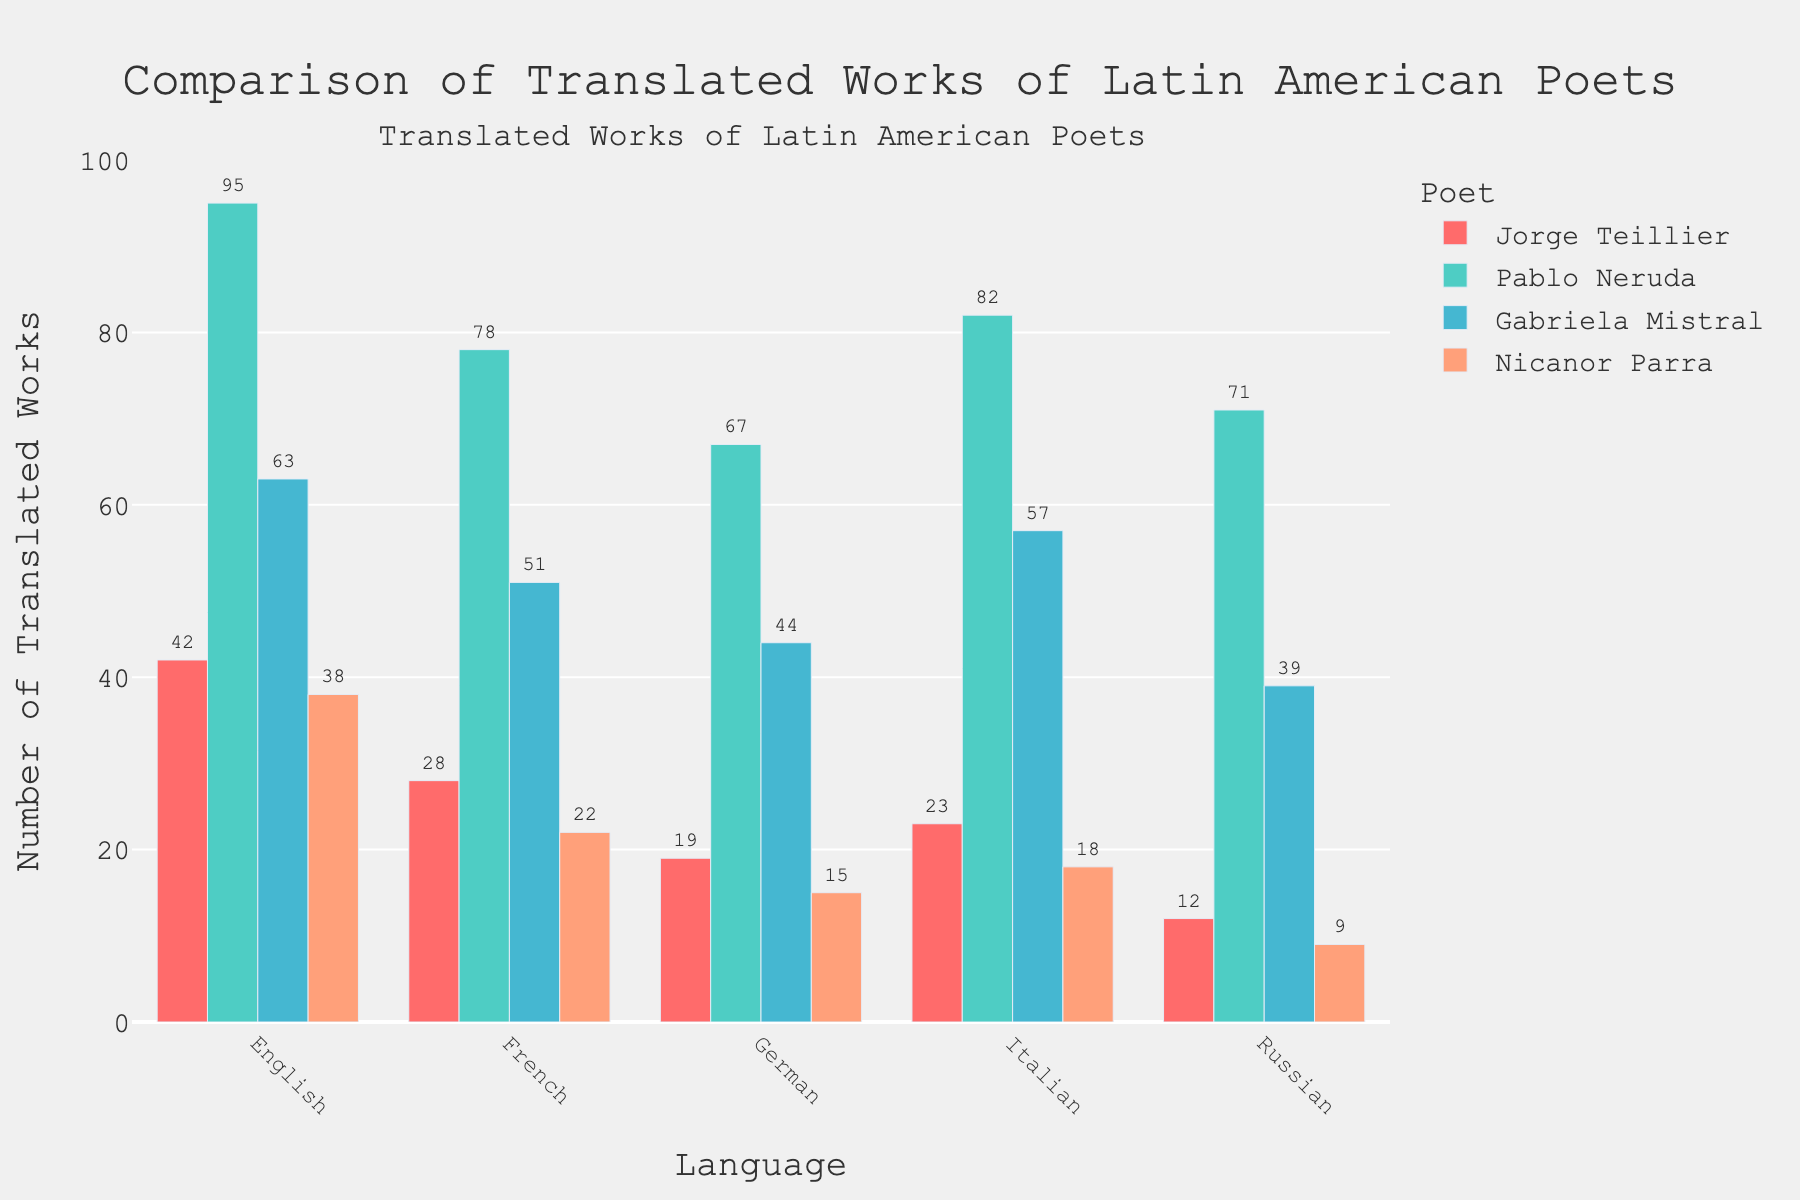Which poet has the highest number of translated works in English? To determine which poet has the highest number of translated works in English, we look for the tallest bar within the "English" category. The tallest bar in the "English" category corresponds to Pablo Neruda with 95 translated works.
Answer: Pablo Neruda How does Jorge Teillier's number of translated works in French compare to his translated works in Italian? To compare Jorge Teillier's translated works in French and Italian, we locate the bars corresponding to these categories for him. Jorge Teillier has 28 translated works in French and 23 in Italian. Therefore, he has more works translated into French.
Answer: More in French (28 vs 23) Which language has the least number of Nicanor Parra's translated works? To find out the language with the least number of Nicanor Parra's translated works, we examine his bars for all languages. The shortest bar belongs to Russian, with 9 translated works.
Answer: Russian What is the total number of translated works for Gabriela Mistral across all languages? To get the total number of translated works for Gabriela Mistral, we add up the values of all her translated works: 63 (English) + 51 (French) + 44 (German) + 57 (Italian) + 39 (Russian), which equals 254.
Answer: 254 Among Jorge Teillier, Pablo Neruda, and Nicanor Parra, who has the fewest translated works in German and what is that number? First, we look at the translated works in German for each poet: Jorge Teillier (19), Pablo Neruda (67), and Nicanor Parra (15). Nicanor Parra has the fewest with 15 translated works.
Answer: Nicanor Parra (15) Which poet has the most consistent number of translated works across all languages in terms of small variance? We need to consider the range of the number of translated works for each poet across all languages. Jorge Teillier's works vary from 12 to 42, Pablo Neruda's from 67 to 95, Gabriela Mistral's from 39 to 63, and Nicanor Parra's from 9 to 38. Therefore, Nicanor Parra shows the most consistent distribution with the smallest variance.
Answer: Nicanor Parra What is the average number of translated works across all languages for Pablo Neruda? To find the average number of translated works for Pablo Neruda, we sum his translations in all languages and divide by 5: (95 + 78 + 67 + 82 + 71) / 5 = 393 / 5 = 78.6.
Answer: 78.6 What is the difference in the number of translated works between Jorge Teillier and Gabriela Mistral in Russian? To find the difference, we subtract the smaller number from the larger number. Gabriela Mistral has 39 translated works in Russian and Jorge Teillier has 12. Thus, the difference is 39 - 12.
Answer: 27 In which language does Gabriela Mistral have her highest number of translated works? To find the language with Gabriela Mistral's highest number of translations, we look for the tallest bar among her data. The highest bar is in the Italian category with 57 translated works.
Answer: Italian 